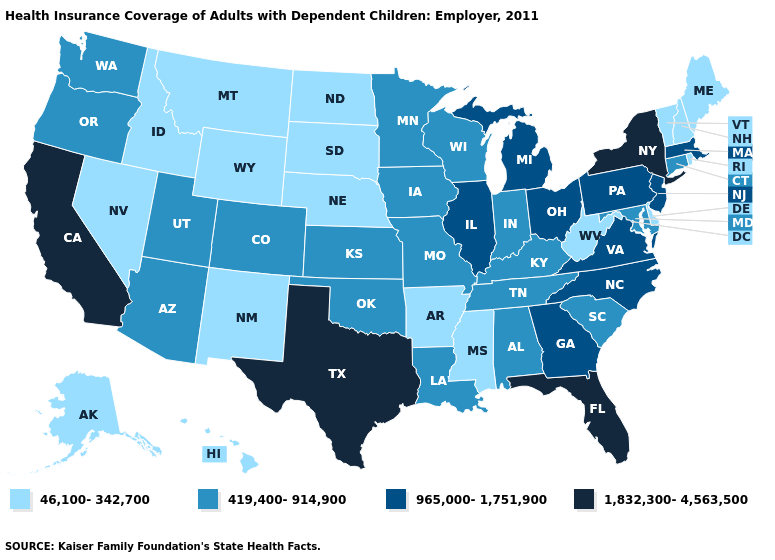Does Connecticut have a higher value than Wyoming?
Concise answer only. Yes. Does the first symbol in the legend represent the smallest category?
Answer briefly. Yes. What is the value of West Virginia?
Concise answer only. 46,100-342,700. What is the value of Connecticut?
Keep it brief. 419,400-914,900. Does Nebraska have a higher value than Louisiana?
Concise answer only. No. How many symbols are there in the legend?
Concise answer only. 4. Which states have the highest value in the USA?
Be succinct. California, Florida, New York, Texas. Which states have the lowest value in the USA?
Give a very brief answer. Alaska, Arkansas, Delaware, Hawaii, Idaho, Maine, Mississippi, Montana, Nebraska, Nevada, New Hampshire, New Mexico, North Dakota, Rhode Island, South Dakota, Vermont, West Virginia, Wyoming. Which states have the lowest value in the USA?
Write a very short answer. Alaska, Arkansas, Delaware, Hawaii, Idaho, Maine, Mississippi, Montana, Nebraska, Nevada, New Hampshire, New Mexico, North Dakota, Rhode Island, South Dakota, Vermont, West Virginia, Wyoming. Which states have the lowest value in the USA?
Quick response, please. Alaska, Arkansas, Delaware, Hawaii, Idaho, Maine, Mississippi, Montana, Nebraska, Nevada, New Hampshire, New Mexico, North Dakota, Rhode Island, South Dakota, Vermont, West Virginia, Wyoming. How many symbols are there in the legend?
Concise answer only. 4. Does Utah have the lowest value in the West?
Be succinct. No. Name the states that have a value in the range 1,832,300-4,563,500?
Give a very brief answer. California, Florida, New York, Texas. Among the states that border Washington , does Oregon have the lowest value?
Answer briefly. No. 